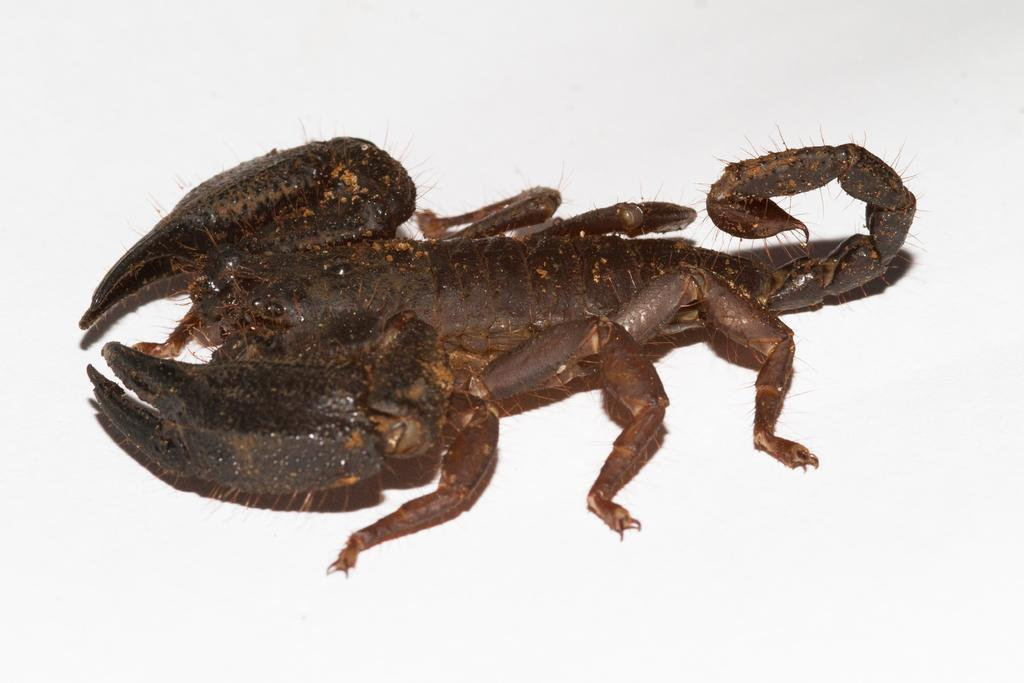What is the main subject in the center of the image? There is a scorpion in the center of the image. What color is the background of the image? The background of the image is white. What type of metal is the lamp made of in the image? There is no lamp present in the image, so it is not possible to determine what type of metal it might be made of. 